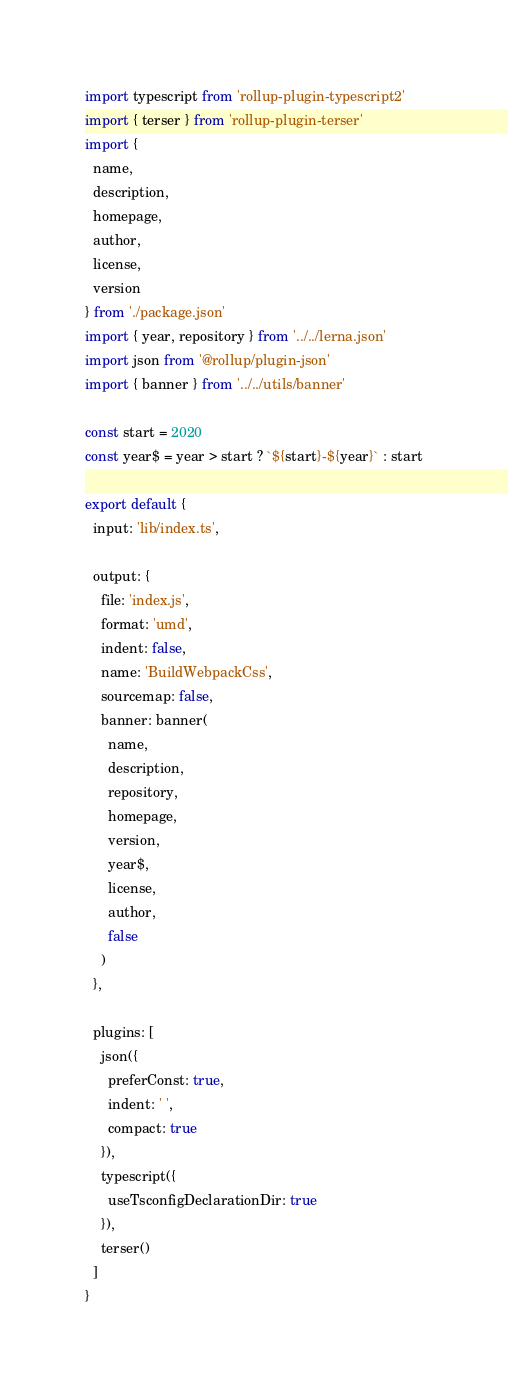Convert code to text. <code><loc_0><loc_0><loc_500><loc_500><_JavaScript_>import typescript from 'rollup-plugin-typescript2'
import { terser } from 'rollup-plugin-terser'
import {
  name,
  description,
  homepage,
  author,
  license,
  version
} from './package.json'
import { year, repository } from '../../lerna.json'
import json from '@rollup/plugin-json'
import { banner } from '../../utils/banner'

const start = 2020
const year$ = year > start ? `${start}-${year}` : start

export default {
  input: 'lib/index.ts',

  output: {
    file: 'index.js',
    format: 'umd',
    indent: false,
    name: 'BuildWebpackCss',
    sourcemap: false,
    banner: banner(
      name,
      description,
      repository,
      homepage,
      version,
      year$,
      license,
      author,
      false
    )
  },

  plugins: [
    json({
      preferConst: true,
      indent: ' ',
      compact: true
    }),
    typescript({
      useTsconfigDeclarationDir: true
    }),
    terser()
  ]
}
</code> 